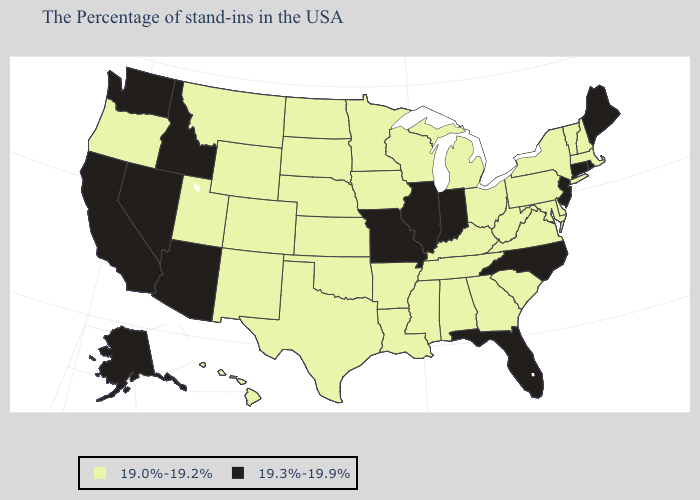What is the lowest value in the USA?
Quick response, please. 19.0%-19.2%. Does the first symbol in the legend represent the smallest category?
Short answer required. Yes. Does Alaska have a higher value than Florida?
Short answer required. No. What is the value of Florida?
Write a very short answer. 19.3%-19.9%. Does Nevada have the lowest value in the West?
Be succinct. No. Among the states that border Maine , which have the lowest value?
Write a very short answer. New Hampshire. What is the lowest value in states that border Texas?
Keep it brief. 19.0%-19.2%. What is the value of Mississippi?
Write a very short answer. 19.0%-19.2%. Among the states that border Massachusetts , does New York have the highest value?
Short answer required. No. What is the lowest value in states that border Florida?
Short answer required. 19.0%-19.2%. Does the first symbol in the legend represent the smallest category?
Write a very short answer. Yes. Name the states that have a value in the range 19.3%-19.9%?
Answer briefly. Maine, Rhode Island, Connecticut, New Jersey, North Carolina, Florida, Indiana, Illinois, Missouri, Arizona, Idaho, Nevada, California, Washington, Alaska. Does Delaware have a lower value than Rhode Island?
Be succinct. Yes. Name the states that have a value in the range 19.3%-19.9%?
Write a very short answer. Maine, Rhode Island, Connecticut, New Jersey, North Carolina, Florida, Indiana, Illinois, Missouri, Arizona, Idaho, Nevada, California, Washington, Alaska. What is the lowest value in the MidWest?
Concise answer only. 19.0%-19.2%. 